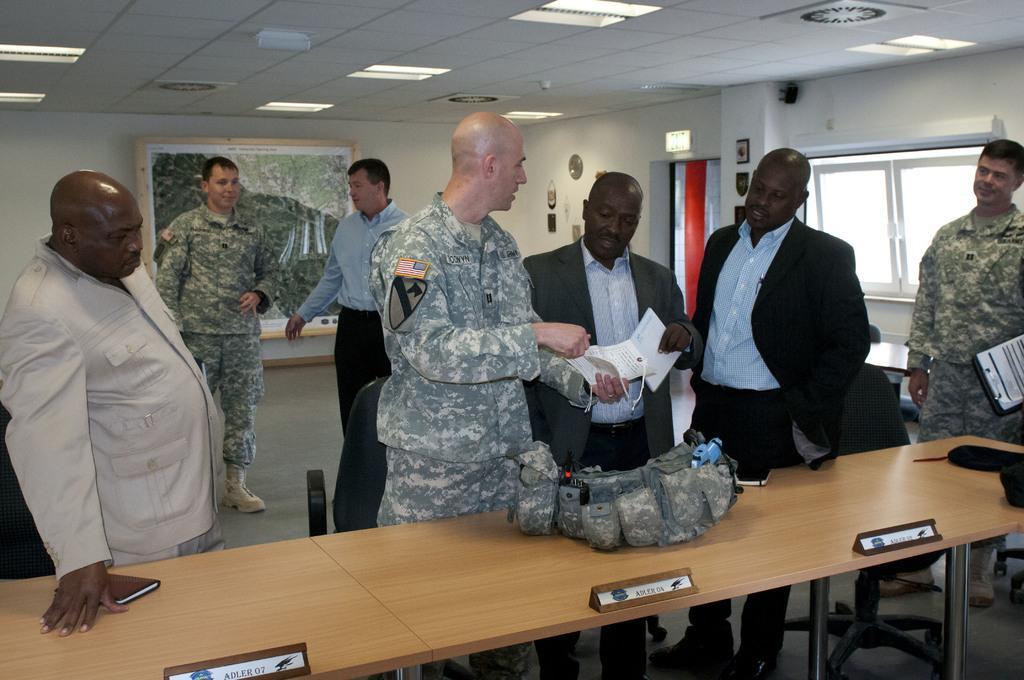Can you describe this image briefly? As we can see in the image there is a wall, windows, photo frame, lights, few people here and there and tables. On table there is a wall. 